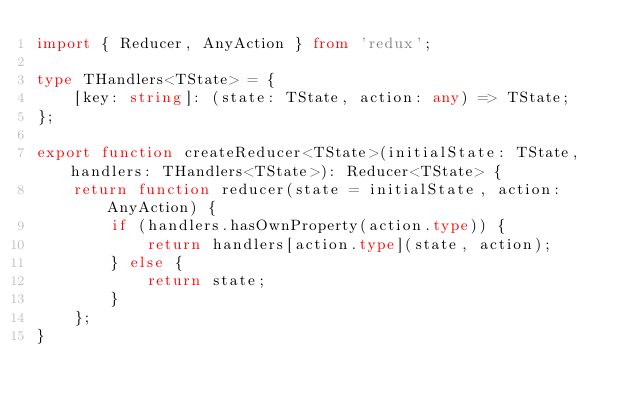<code> <loc_0><loc_0><loc_500><loc_500><_TypeScript_>import { Reducer, AnyAction } from 'redux';

type THandlers<TState> = {
	[key: string]: (state: TState, action: any) => TState;
};

export function createReducer<TState>(initialState: TState, handlers: THandlers<TState>): Reducer<TState> {
	return function reducer(state = initialState, action: AnyAction) {
		if (handlers.hasOwnProperty(action.type)) {
			return handlers[action.type](state, action);
		} else {
			return state;
		}
	};
}
</code> 